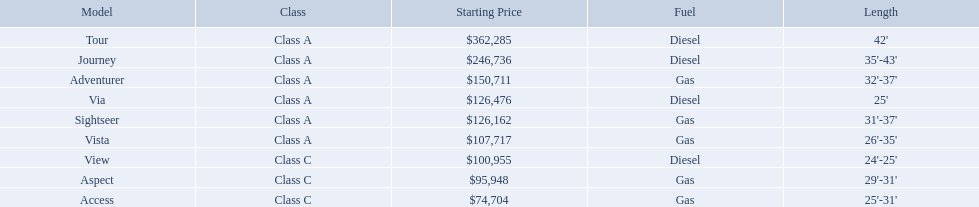Which of the models in the table use diesel fuel? Tour, Journey, Via, View. Of these models, which are class a? Tour, Journey, Via. Which of them are greater than 35' in length? Tour, Journey. Which of the two models is more expensive? Tour. What is the highest price of a winnebago model? $362,285. What is the name of the vehicle with this price? Tour. 